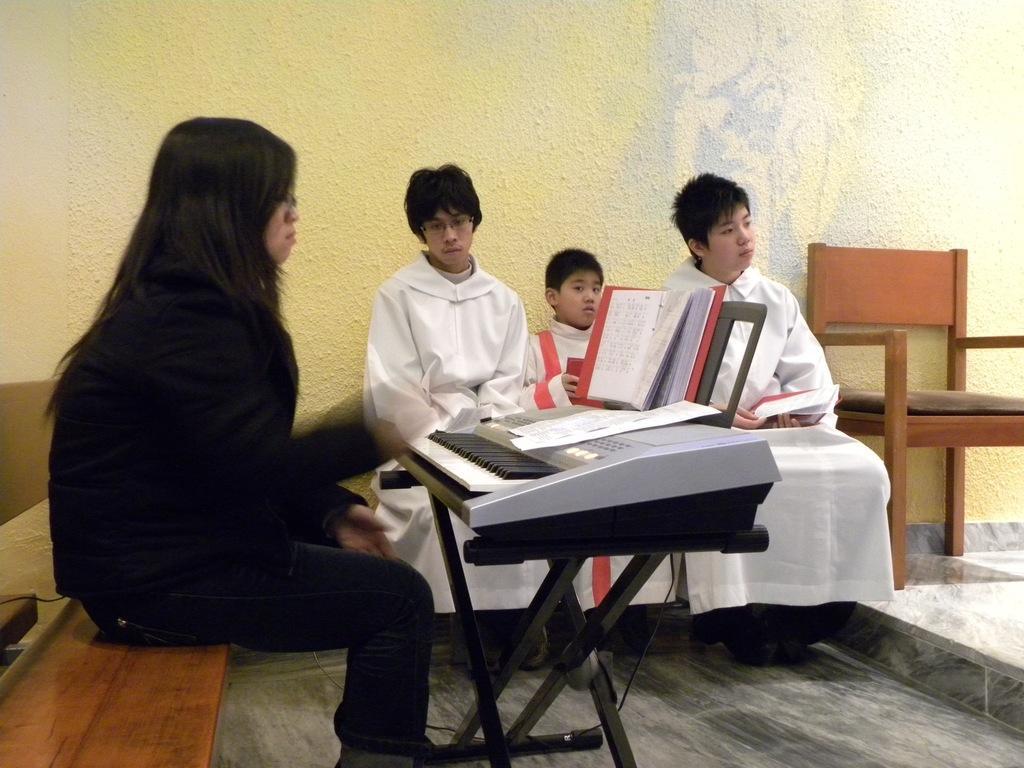Can you describe this image briefly? in the picture there are people sitting on the bench in front of a woman there is a piano 